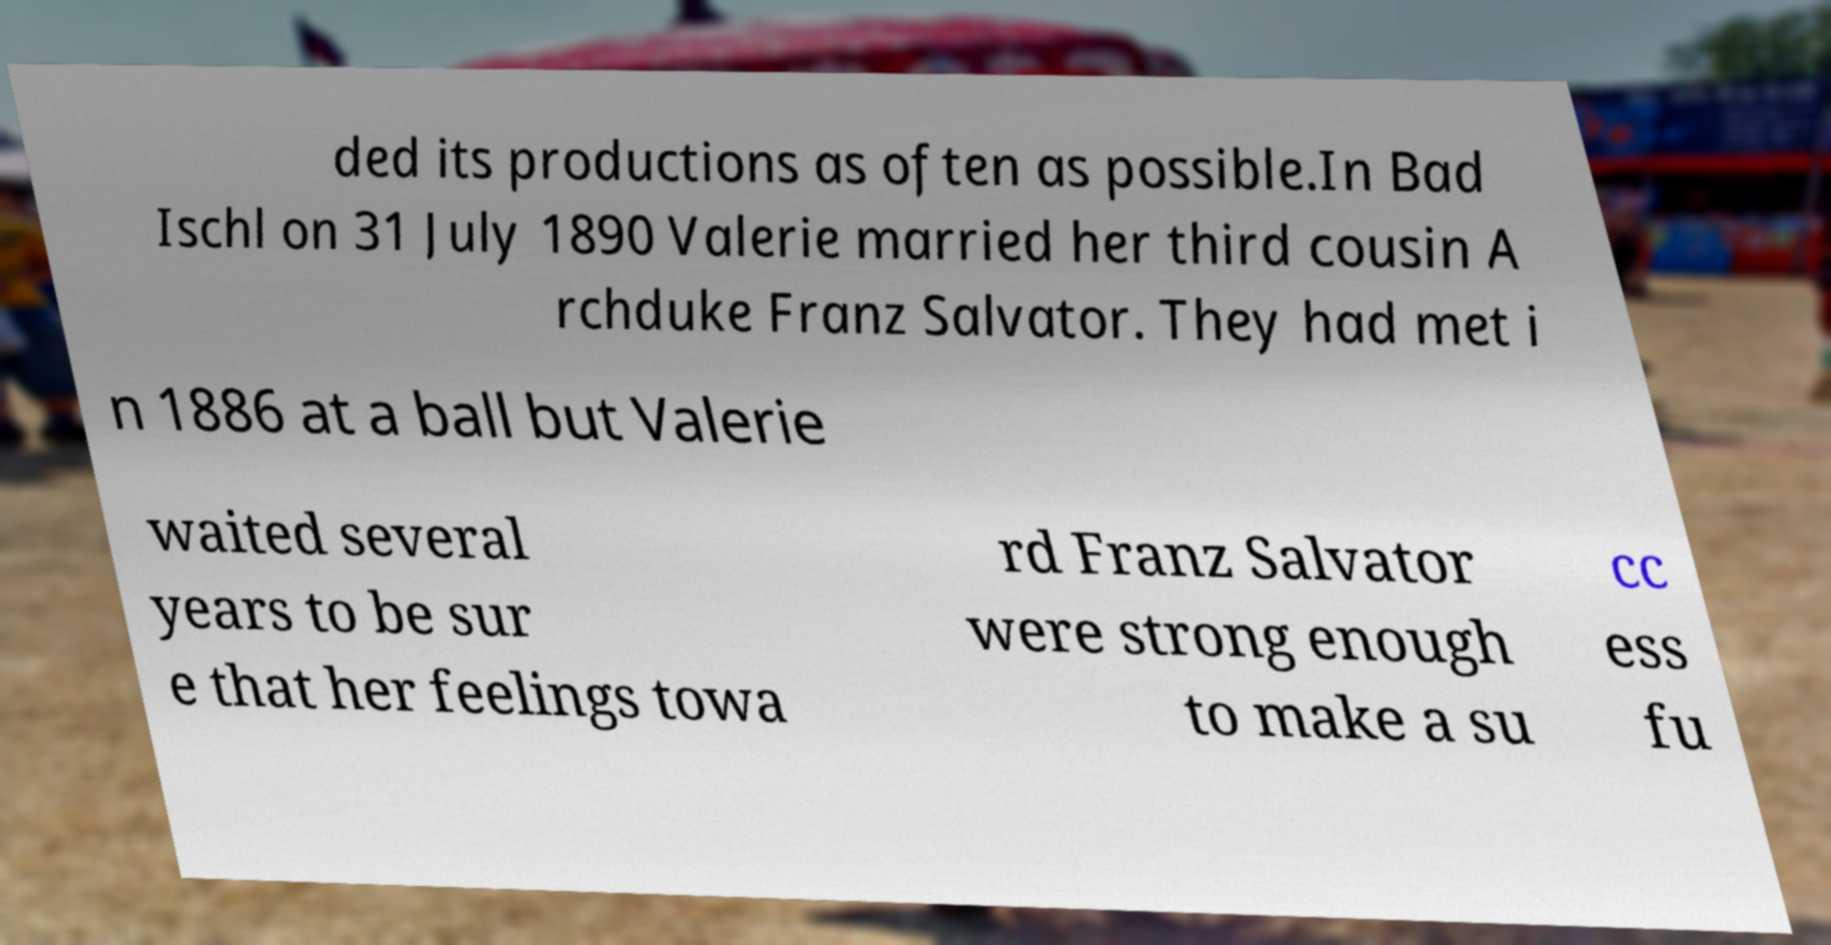Could you extract and type out the text from this image? ded its productions as often as possible.In Bad Ischl on 31 July 1890 Valerie married her third cousin A rchduke Franz Salvator. They had met i n 1886 at a ball but Valerie waited several years to be sur e that her feelings towa rd Franz Salvator were strong enough to make a su cc ess fu 